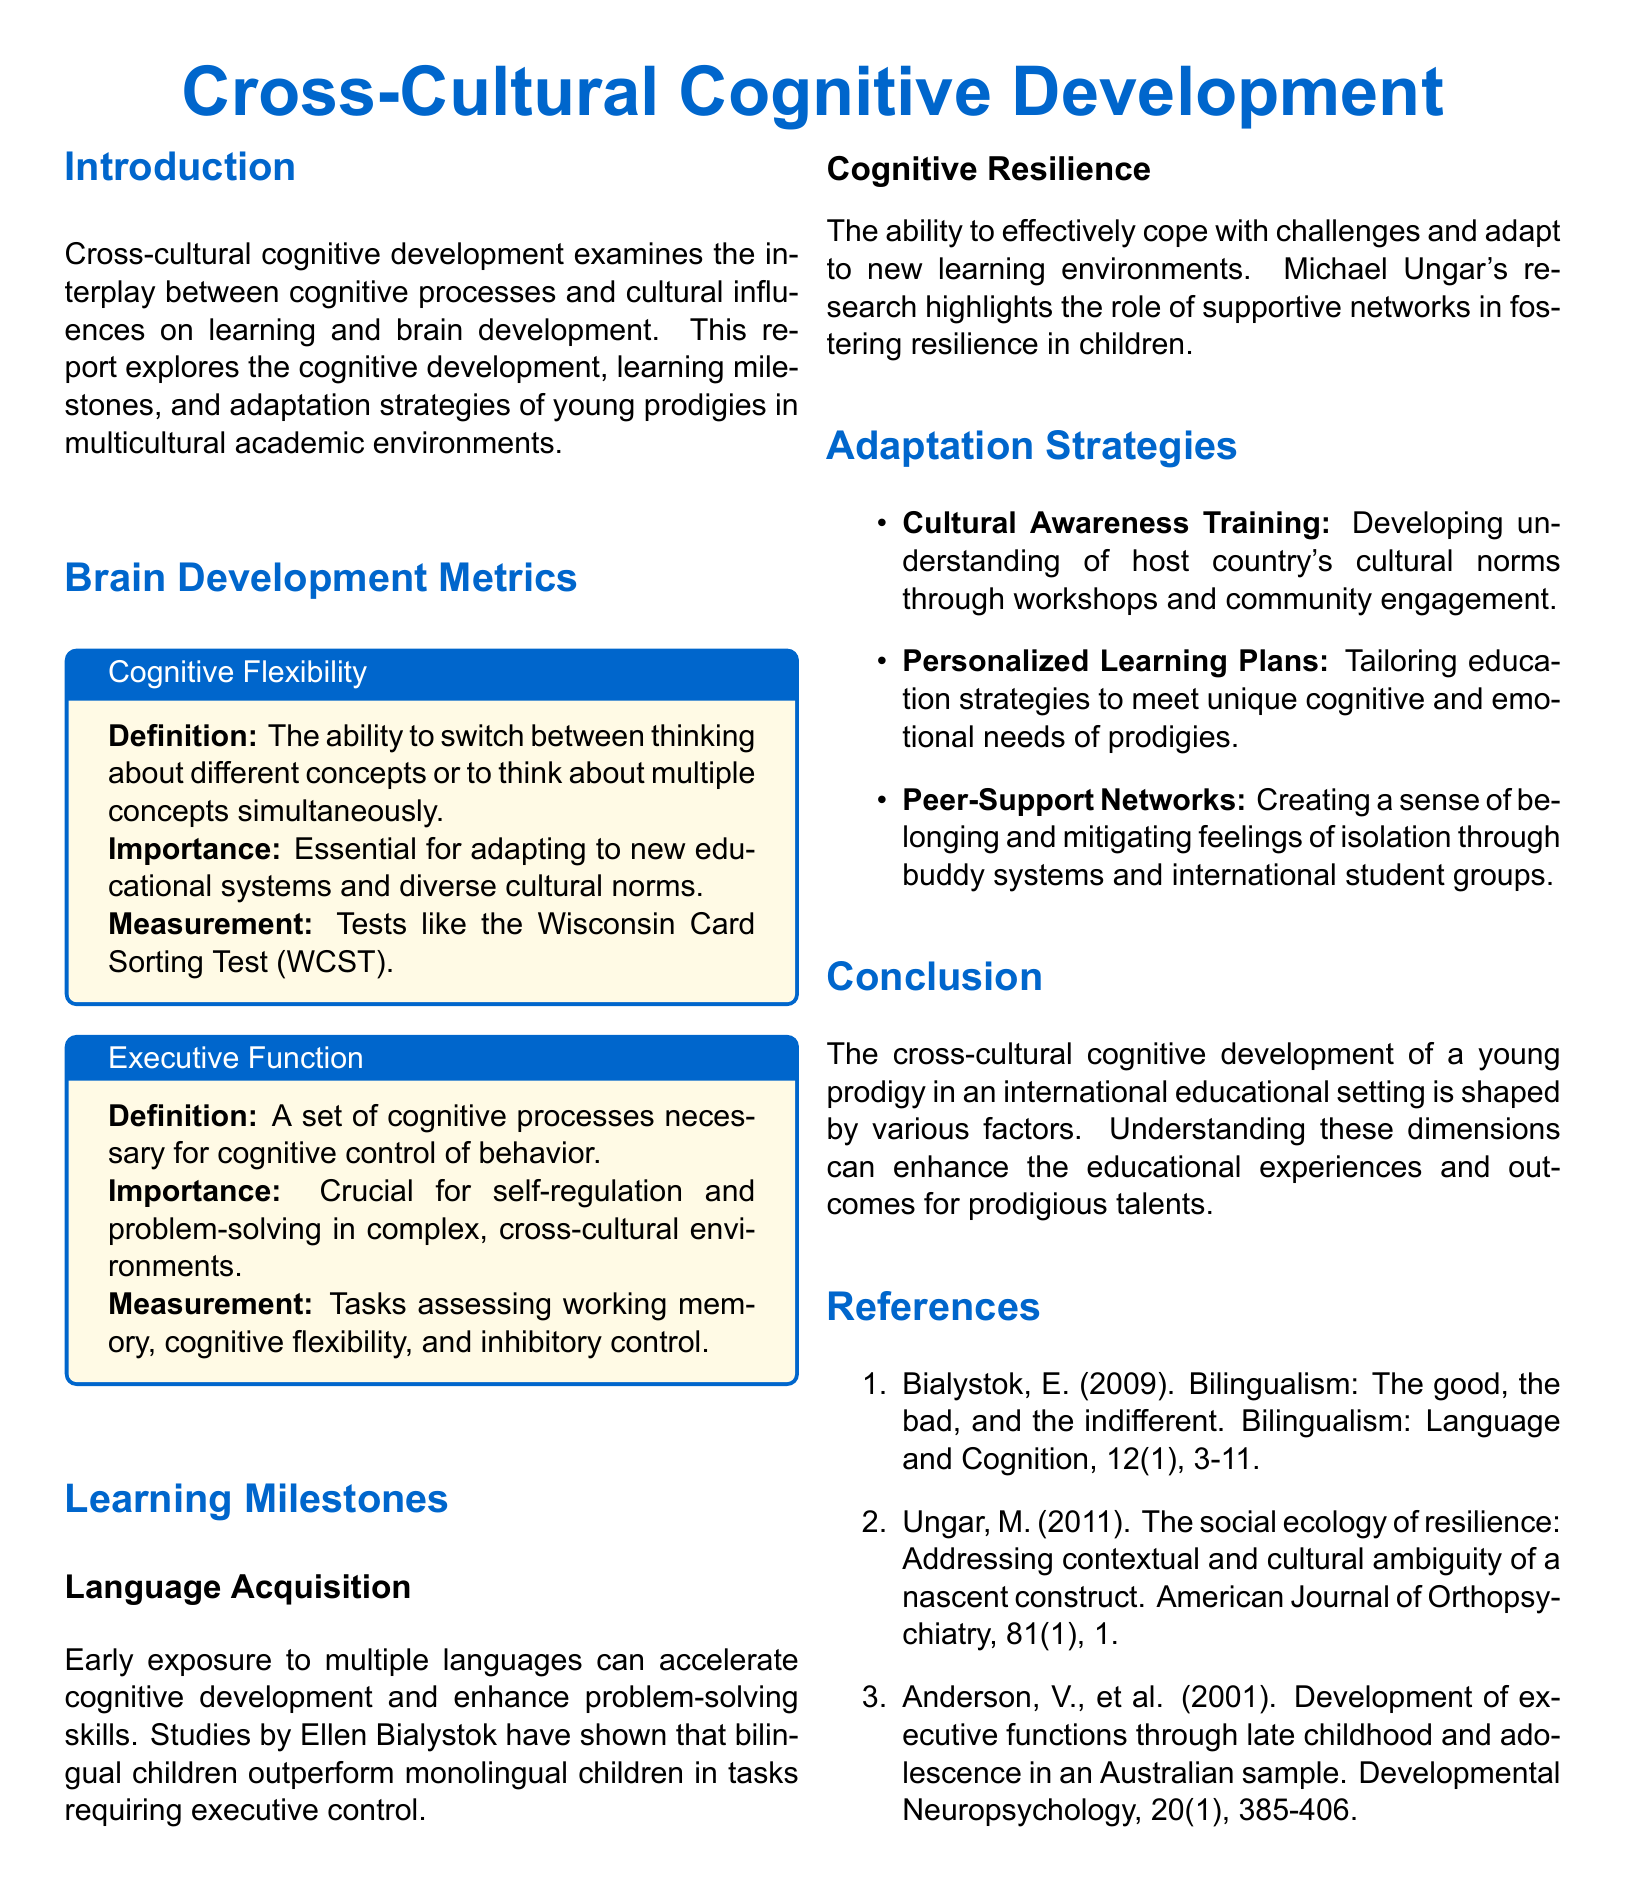What is the main focus of the report? The report focuses on the interplay between cognitive processes and cultural influences on learning and brain development.
Answer: Cross-cultural cognitive development What is one of the measurements for cognitive flexibility? Cognitive flexibility can be measured using tools like the Wisconsin Card Sorting Test.
Answer: Wisconsin Card Sorting Test Who conducted research showing that bilingual children outperform monolingual children? Ellen Bialystok's studies indicated the advantages of bilingualism in cognitive tasks.
Answer: Ellen Bialystok What is an adaptation strategy mentioned in the report? The report lists cultural awareness training as one of the adaptation strategies.
Answer: Cultural Awareness Training Which research highlights the importance of supportive networks in fostering resilience? Michael Ungar's research emphasizes the role of supportive networks in developing resilience.
Answer: Michael Ungar What aspect of cognitive development does the report aim to enhance? The report aims to enhance educational experiences and outcomes for prodigious talents.
Answer: Educational experiences and outcomes What does executive function refer to? Executive function is a set of cognitive processes necessary for cognitive control of behavior.
Answer: Cognitive control of behavior What type of training helps understand host country's cultural norms? Cultural awareness training aids in understanding the cultural norms of the host country.
Answer: Cultural awareness training What year was the American Journal of Orthopsychiatry article by Ungar published? Michael Ungar's article was published in 2011.
Answer: 2011 